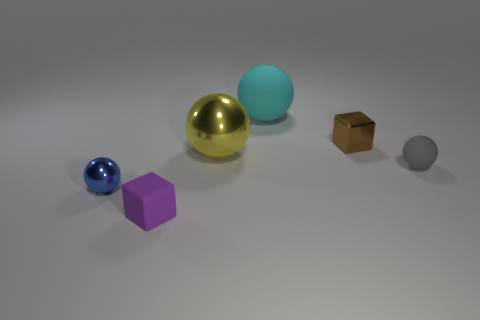Subtract all large cyan balls. How many balls are left? 3 Add 1 cyan matte cylinders. How many objects exist? 7 Subtract 1 blocks. How many blocks are left? 1 Subtract all blue spheres. How many spheres are left? 3 Subtract all blocks. How many objects are left? 4 Subtract all cyan cubes. Subtract all purple balls. How many cubes are left? 2 Subtract all brown cylinders. How many blue cubes are left? 0 Subtract all small purple things. Subtract all tiny brown matte cubes. How many objects are left? 5 Add 6 brown shiny things. How many brown shiny things are left? 7 Add 2 big yellow spheres. How many big yellow spheres exist? 3 